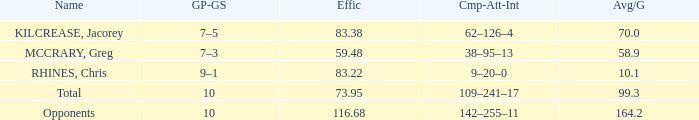What is the avg/g for chris rhines when his effic is more than 73.95? 10.1. 